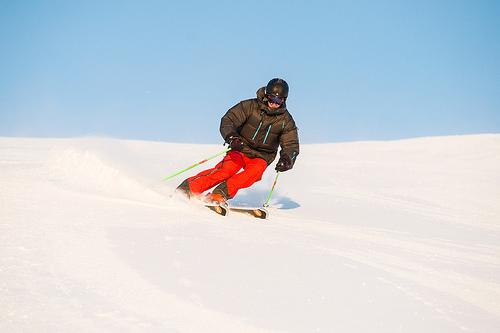Mention the color of the sky and the ground in the image, as well as the action the skier is performing. Under a clear blue sky, the skier is skiing on the white snow, leaning to the side. List three colorful items in the image associated with the skier. Red and black pants, green ski poles, and a blue string on a coat. For the product advertisement task, describe the skier's jacket and its features. The skier is wearing a black puffy winter jacket with a stylish design, including two blue stripes, providing warmth and comfort while skiing. For the multi choice VQA task, select the accurate description of the skier's pants. The skier is wearing red and black snow pants. What safety gear is the skier wearing in the image? Provide details about the gear. The skier is wearing a black helmet and ski goggles to protect their head and face while skiing. If you were to create a referential expression grounding task, describe the individual elements associated with the skier's ski equipment. Red skis, green ski poles, and a black and white ski. Explain the setting and environmental conditions in the image. The photo was taken during winter on a white snowy slope, with a clear blue sky and no cloud in sight. Pick a prominent feature of the skier and describe it. The skier is wearing a black puffy winter jacket with two blue stripes on it. Identify the primary activity of the person captured in the image. A person is skiing downhill on a snowy slope. Create a visual entailment task by analyzing the overall image and mentioning the key components. In the image, a person wearing a black puffy jacket, red and black pants, a black helmet, and ski goggles is skiing downhill on a white snowy slope with skis and green ski poles under a clear blue sky. 